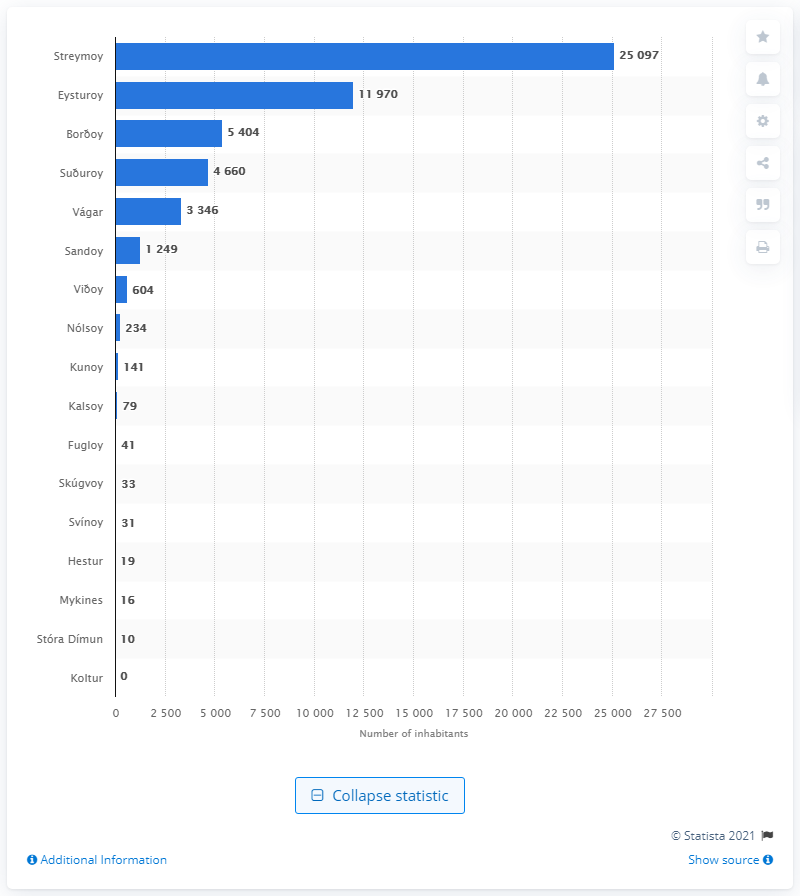Identify some key points in this picture. The largest island in the Faroe Islands is Streymoy. 